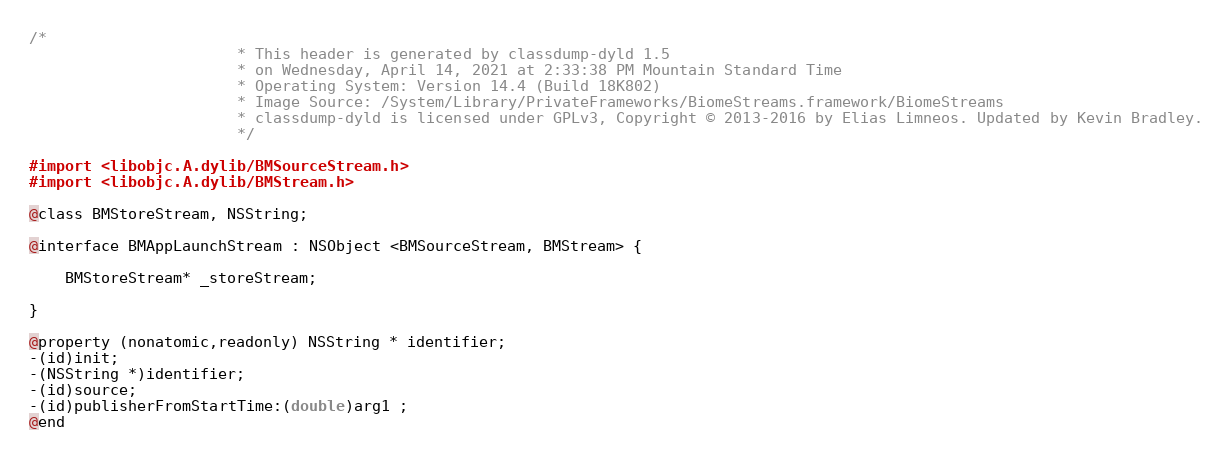<code> <loc_0><loc_0><loc_500><loc_500><_C_>/*
                       * This header is generated by classdump-dyld 1.5
                       * on Wednesday, April 14, 2021 at 2:33:38 PM Mountain Standard Time
                       * Operating System: Version 14.4 (Build 18K802)
                       * Image Source: /System/Library/PrivateFrameworks/BiomeStreams.framework/BiomeStreams
                       * classdump-dyld is licensed under GPLv3, Copyright © 2013-2016 by Elias Limneos. Updated by Kevin Bradley.
                       */

#import <libobjc.A.dylib/BMSourceStream.h>
#import <libobjc.A.dylib/BMStream.h>

@class BMStoreStream, NSString;

@interface BMAppLaunchStream : NSObject <BMSourceStream, BMStream> {

	BMStoreStream* _storeStream;

}

@property (nonatomic,readonly) NSString * identifier; 
-(id)init;
-(NSString *)identifier;
-(id)source;
-(id)publisherFromStartTime:(double)arg1 ;
@end

</code> 